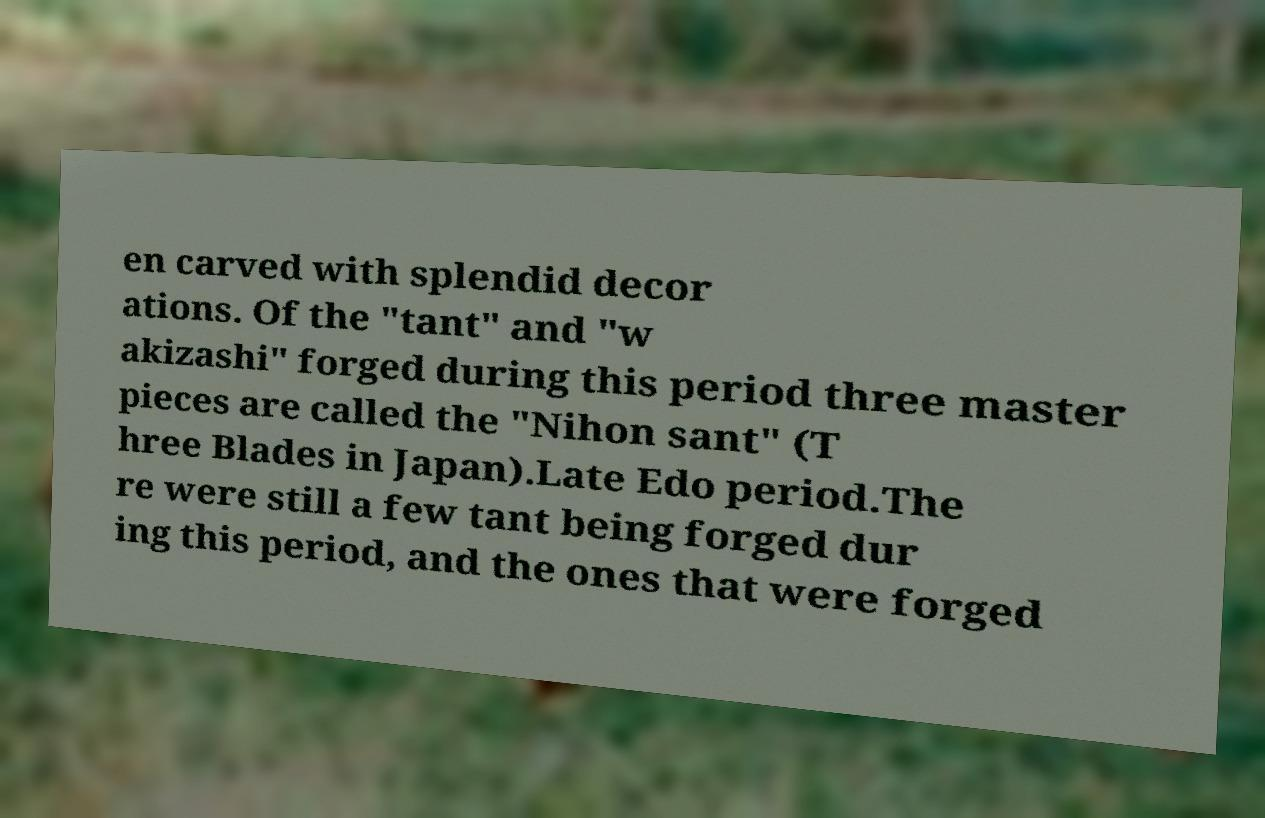What messages or text are displayed in this image? I need them in a readable, typed format. en carved with splendid decor ations. Of the "tant" and "w akizashi" forged during this period three master pieces are called the "Nihon sant" (T hree Blades in Japan).Late Edo period.The re were still a few tant being forged dur ing this period, and the ones that were forged 